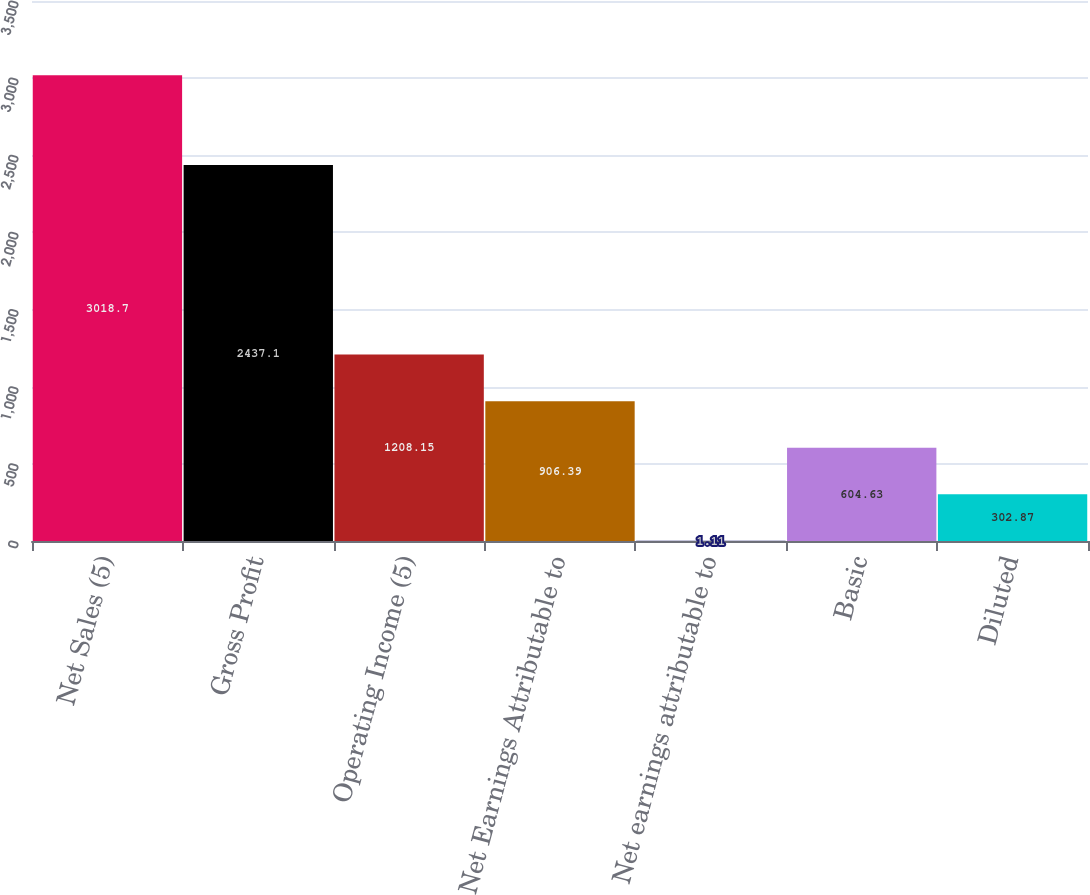Convert chart to OTSL. <chart><loc_0><loc_0><loc_500><loc_500><bar_chart><fcel>Net Sales (5)<fcel>Gross Profit<fcel>Operating Income (5)<fcel>Net Earnings Attributable to<fcel>Net earnings attributable to<fcel>Basic<fcel>Diluted<nl><fcel>3018.7<fcel>2437.1<fcel>1208.15<fcel>906.39<fcel>1.11<fcel>604.63<fcel>302.87<nl></chart> 